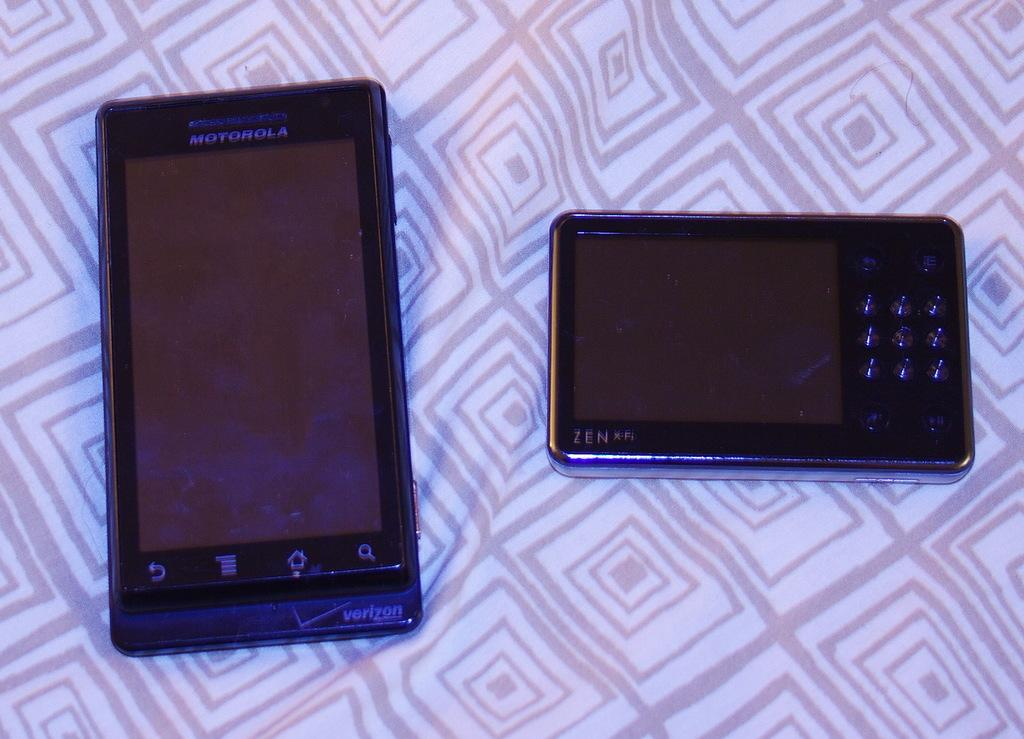Provide a one-sentence caption for the provided image. A black Motorola cell phone and a black ZEN X-Fi device laying on top of some type of material. 